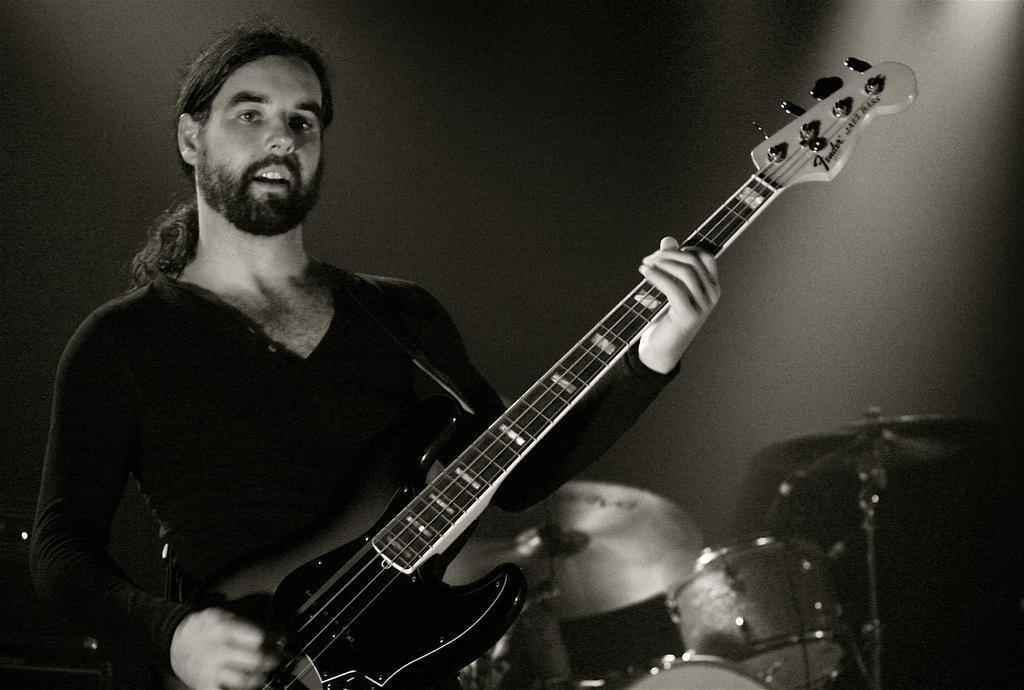Please provide a concise description of this image. Person playing guitar,this is drum. 